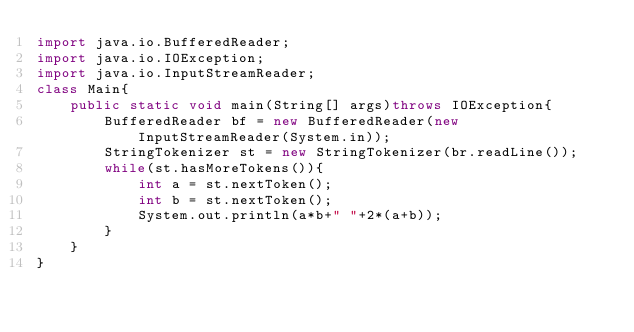<code> <loc_0><loc_0><loc_500><loc_500><_Java_>import java.io.BufferedReader;
import java.io.IOException;
import java.io.InputStreamReader;
class Main{
    public static void main(String[] args)throws IOException{
        BufferedReader bf = new BufferedReader(new InputStreamReader(System.in));
		StringTokenizer st = new StringTokenizer(br.readLine());
        while(st.hasMoreTokens()){
            int a = st.nextToken();
            int b = st.nextToken();
            System.out.println(a*b+" "+2*(a+b));
        }
    }
}</code> 